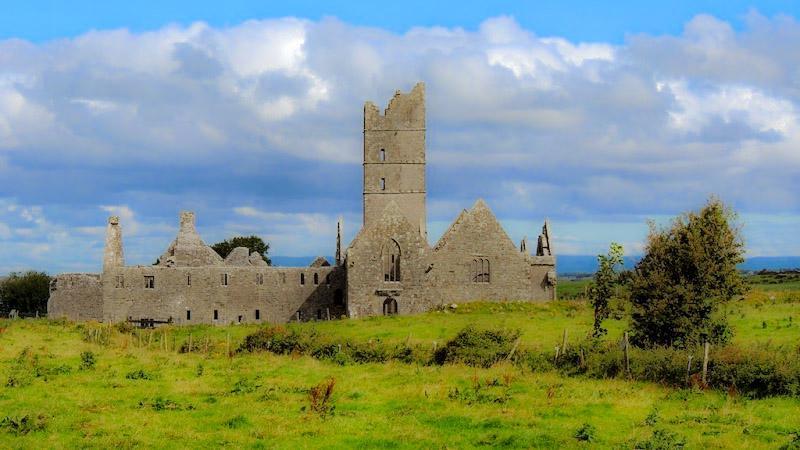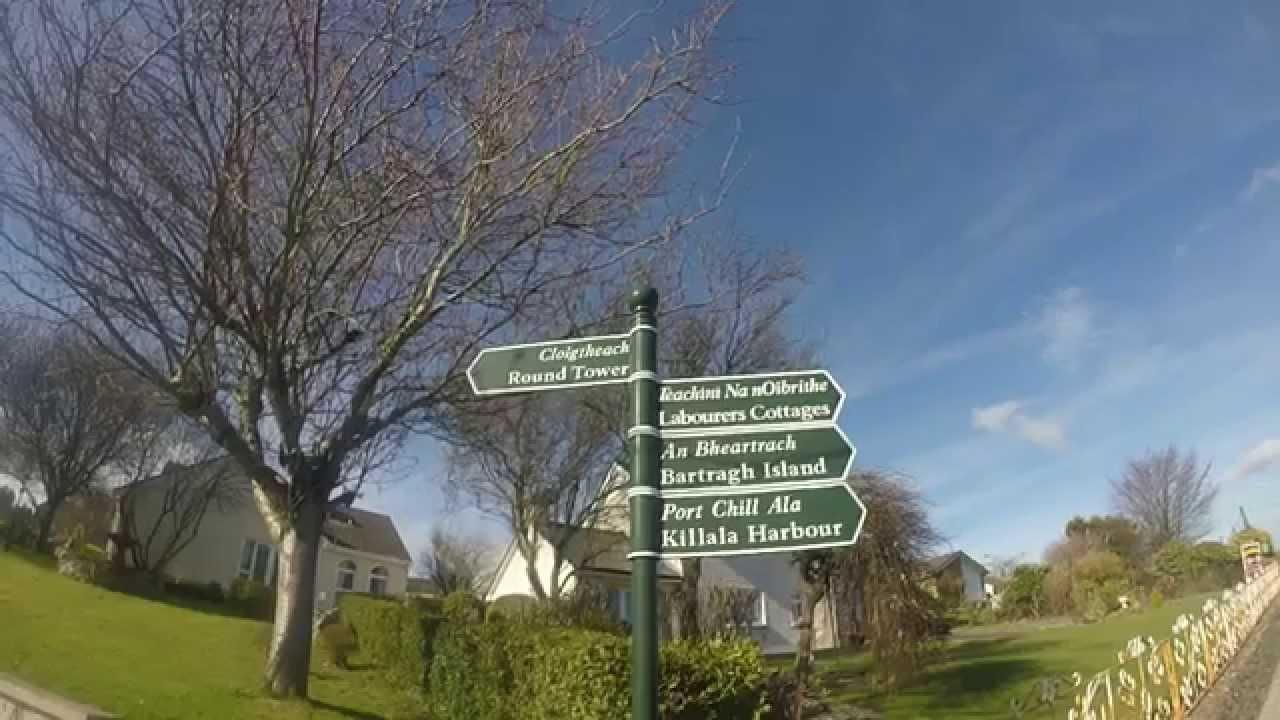The first image is the image on the left, the second image is the image on the right. Examine the images to the left and right. Is the description "There is a castle with a broken tower in the image on the left." accurate? Answer yes or no. Yes. 